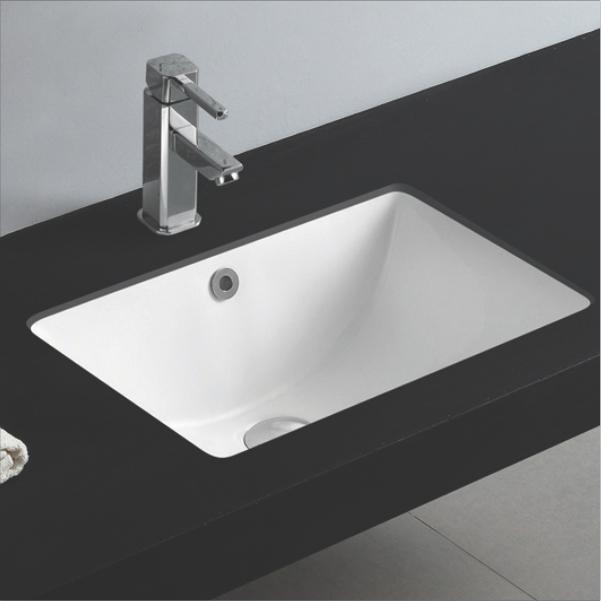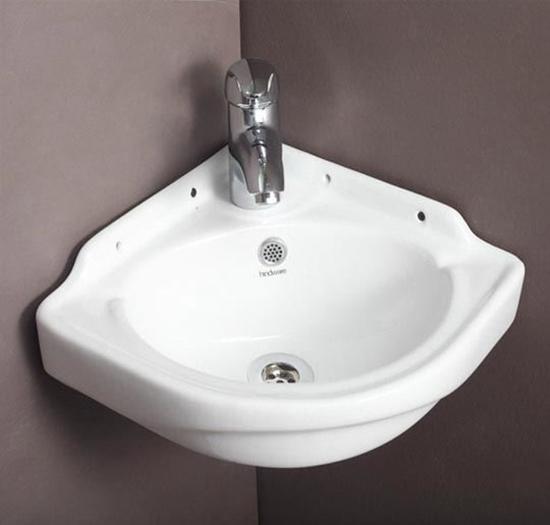The first image is the image on the left, the second image is the image on the right. For the images shown, is this caption "One of the sinks is set into a flat counter that is a different color than the sink." true? Answer yes or no. Yes. 